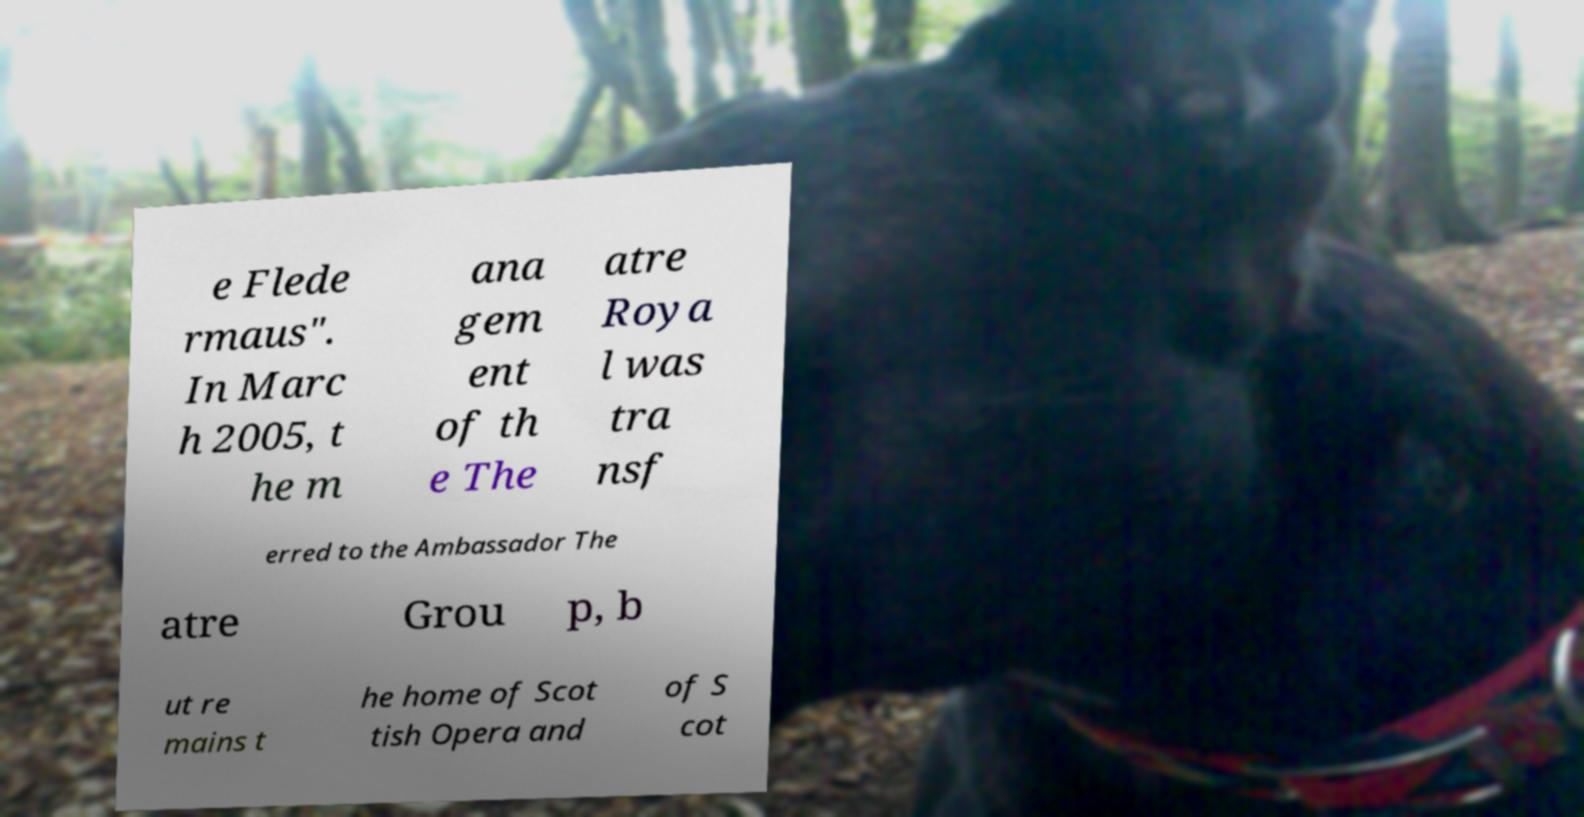Please read and relay the text visible in this image. What does it say? e Flede rmaus". In Marc h 2005, t he m ana gem ent of th e The atre Roya l was tra nsf erred to the Ambassador The atre Grou p, b ut re mains t he home of Scot tish Opera and of S cot 